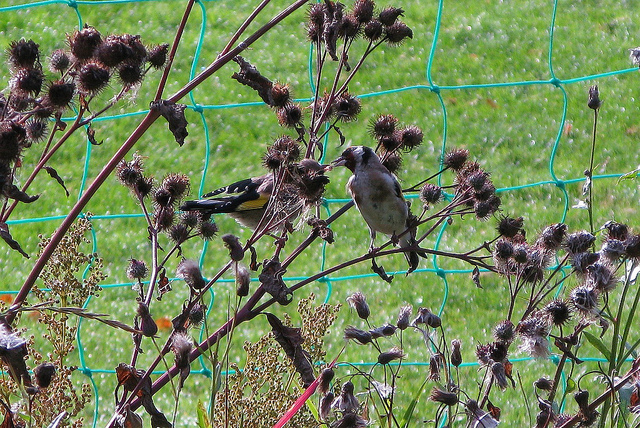<image>What kind of tree is this? I don't know what kind of tree it is. It can be oak, maple, walnut, thistle, burdock or seed. What kind of tree is this? I am not sure what kind of tree this is. It can be oak, maple, walnut or something else. 